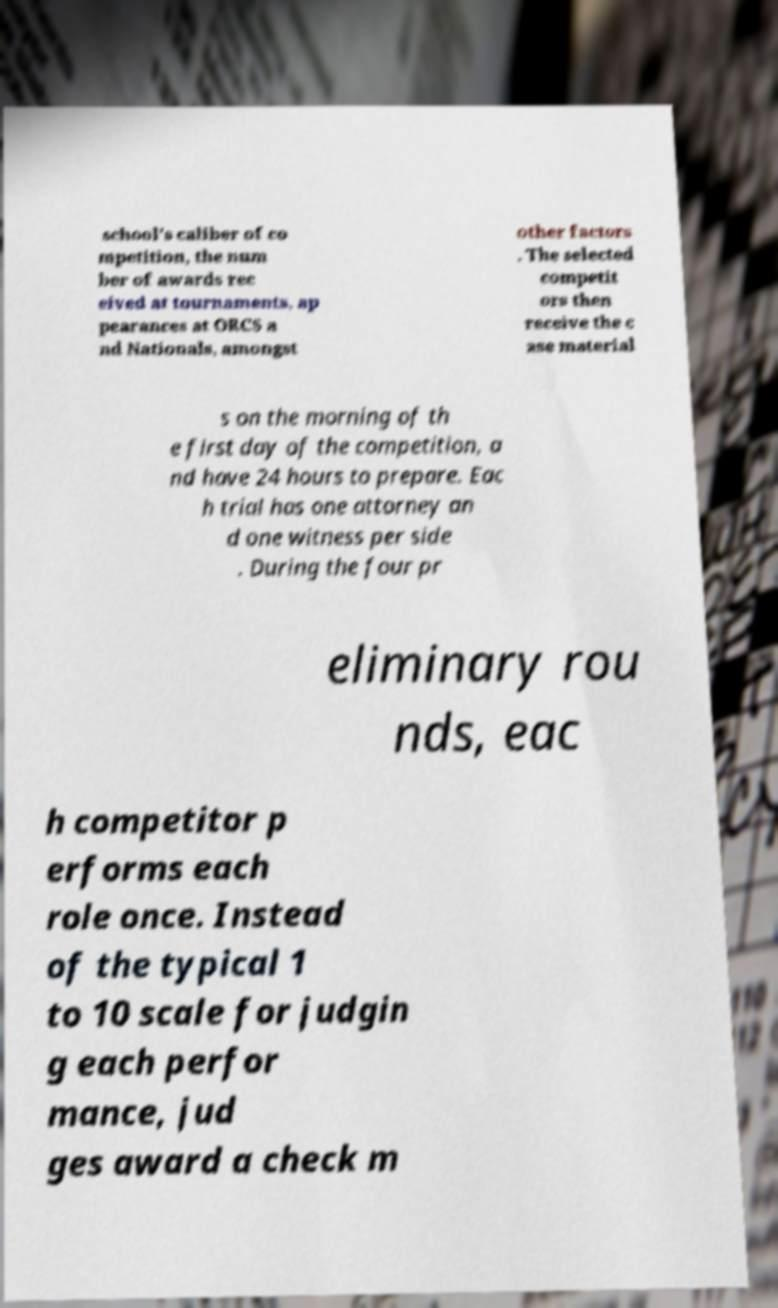Can you read and provide the text displayed in the image?This photo seems to have some interesting text. Can you extract and type it out for me? school's caliber of co mpetition, the num ber of awards rec eived at tournaments, ap pearances at ORCS a nd Nationals, amongst other factors . The selected competit ors then receive the c ase material s on the morning of th e first day of the competition, a nd have 24 hours to prepare. Eac h trial has one attorney an d one witness per side . During the four pr eliminary rou nds, eac h competitor p erforms each role once. Instead of the typical 1 to 10 scale for judgin g each perfor mance, jud ges award a check m 